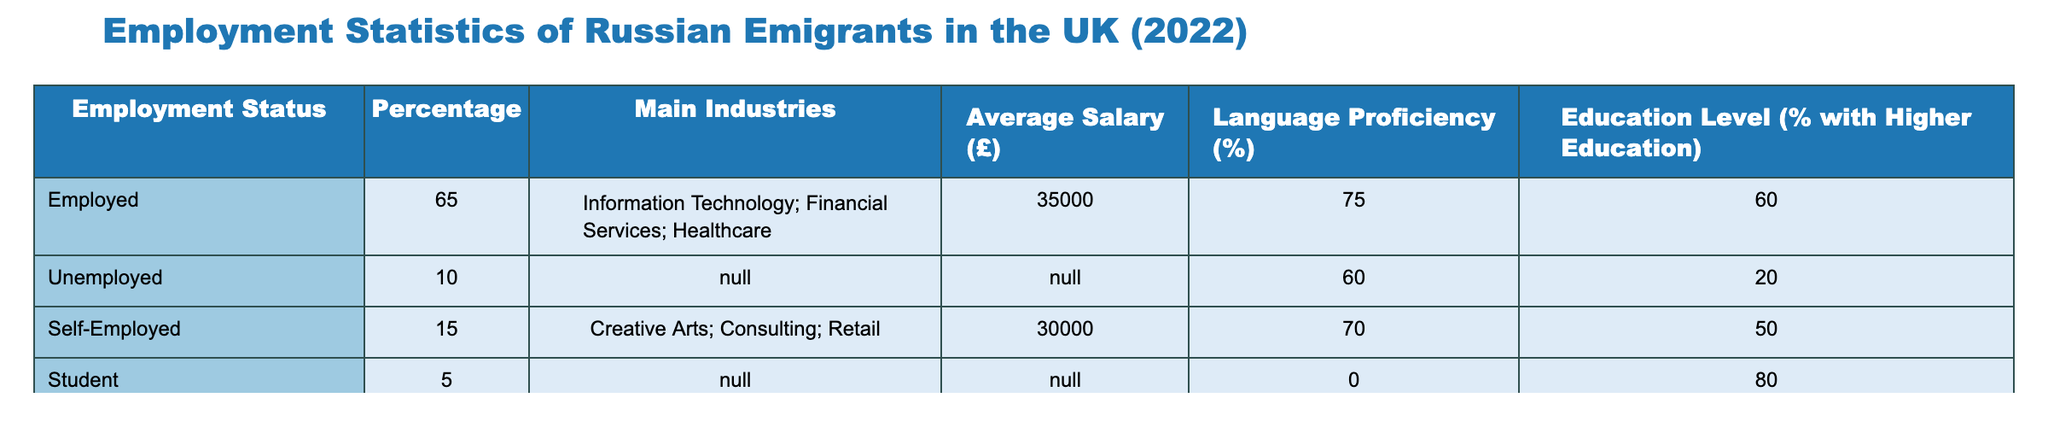What percentage of Russian emigrants in the UK were employed in 2022? The table indicates that the percentage of employed Russian emigrants in the UK in 2022 is listed under the Employment Status column for "Employed," which shows a value of 65%.
Answer: 65% What is the average salary for self-employed Russian emigrants in the UK? According to the table, the average salary listed for self-employed Russian emigrants is £30,000.
Answer: £30,000 What percentage of unemployed Russian emigrants were reported in 2022? The table specifies the percentage of unemployed individuals under the Employment Status column, which lists "Unemployed" at 10%.
Answer: 10% What is the average language proficiency among employed Russian emigrants? The table provides a language proficiency percentage for employed Russian emigrants as 75%.
Answer: 75% What is the combined percentage of self-employed and unemployed Russian emigrants? To determine this, we add the percentages for self-employed (15%) and unemployed (10%) individuals: 15 + 10 = 25%.
Answer: 25% Is the percentage of Russian emigrants who are students higher than those who are unemployed? Comparing the percentages, we see that 5% of Russian emigrants are students, while 10% are unemployed. Since 5% is less than 10%, the statement is false.
Answer: No What percentage of Russian emigrants with higher education are employed? The table shows that 60% of employed individuals have higher education, referring specifically to the employed category.
Answer: 60% How many more Russian emigrants are employed compared to self-employed in percentage terms? The table lists 65% employed and 15% self-employed. The difference is calculated as 65 - 15 = 50%.
Answer: 50% What is the total percentage of Russian emigrants who are either employed or self-employed? To find this, we sum the percentages for employed (65%) and self-employed (15%): 65 + 15 = 80%.
Answer: 80% 